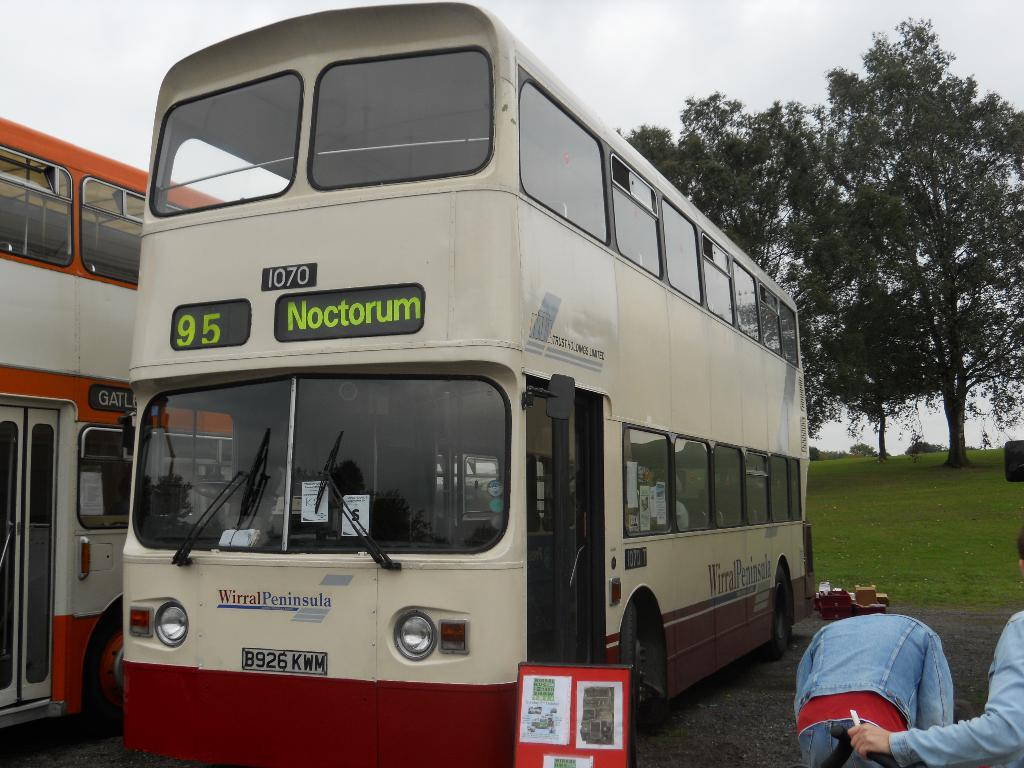What type of vehicles can be seen in the image? There are buses in the image. What else is present in the image besides the buses? There is a poster, grass, two people on the right side, trees, and the sky visible at the top of the image. What type of knot is being tied by the scarecrow in the image? There is no scarecrow present in the image. 